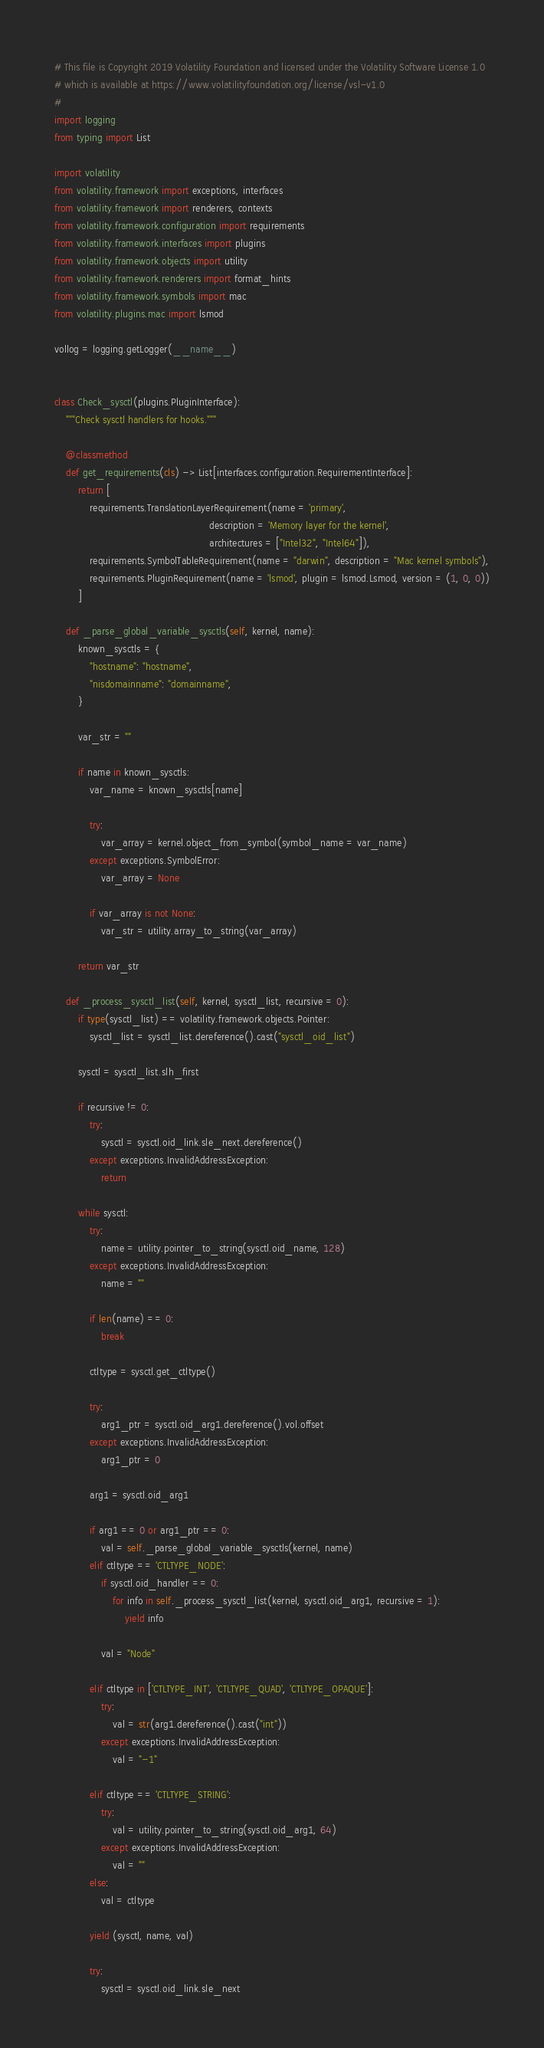Convert code to text. <code><loc_0><loc_0><loc_500><loc_500><_Python_># This file is Copyright 2019 Volatility Foundation and licensed under the Volatility Software License 1.0
# which is available at https://www.volatilityfoundation.org/license/vsl-v1.0
#
import logging
from typing import List

import volatility
from volatility.framework import exceptions, interfaces
from volatility.framework import renderers, contexts
from volatility.framework.configuration import requirements
from volatility.framework.interfaces import plugins
from volatility.framework.objects import utility
from volatility.framework.renderers import format_hints
from volatility.framework.symbols import mac
from volatility.plugins.mac import lsmod

vollog = logging.getLogger(__name__)


class Check_sysctl(plugins.PluginInterface):
    """Check sysctl handlers for hooks."""

    @classmethod
    def get_requirements(cls) -> List[interfaces.configuration.RequirementInterface]:
        return [
            requirements.TranslationLayerRequirement(name = 'primary',
                                                     description = 'Memory layer for the kernel',
                                                     architectures = ["Intel32", "Intel64"]),
            requirements.SymbolTableRequirement(name = "darwin", description = "Mac kernel symbols"),
            requirements.PluginRequirement(name = 'lsmod', plugin = lsmod.Lsmod, version = (1, 0, 0))
        ]

    def _parse_global_variable_sysctls(self, kernel, name):
        known_sysctls = {
            "hostname": "hostname",
            "nisdomainname": "domainname",
        }

        var_str = ""

        if name in known_sysctls:
            var_name = known_sysctls[name]

            try:
                var_array = kernel.object_from_symbol(symbol_name = var_name)
            except exceptions.SymbolError:
                var_array = None

            if var_array is not None:
                var_str = utility.array_to_string(var_array)

        return var_str

    def _process_sysctl_list(self, kernel, sysctl_list, recursive = 0):
        if type(sysctl_list) == volatility.framework.objects.Pointer:
            sysctl_list = sysctl_list.dereference().cast("sysctl_oid_list")

        sysctl = sysctl_list.slh_first

        if recursive != 0:
            try:
                sysctl = sysctl.oid_link.sle_next.dereference()
            except exceptions.InvalidAddressException:
                return

        while sysctl:
            try:
                name = utility.pointer_to_string(sysctl.oid_name, 128)
            except exceptions.InvalidAddressException:
                name = ""

            if len(name) == 0:
                break

            ctltype = sysctl.get_ctltype()

            try:
                arg1_ptr = sysctl.oid_arg1.dereference().vol.offset
            except exceptions.InvalidAddressException:
                arg1_ptr = 0

            arg1 = sysctl.oid_arg1

            if arg1 == 0 or arg1_ptr == 0:
                val = self._parse_global_variable_sysctls(kernel, name)
            elif ctltype == 'CTLTYPE_NODE':
                if sysctl.oid_handler == 0:
                    for info in self._process_sysctl_list(kernel, sysctl.oid_arg1, recursive = 1):
                        yield info

                val = "Node"

            elif ctltype in ['CTLTYPE_INT', 'CTLTYPE_QUAD', 'CTLTYPE_OPAQUE']:
                try:
                    val = str(arg1.dereference().cast("int"))
                except exceptions.InvalidAddressException:
                    val = "-1"

            elif ctltype == 'CTLTYPE_STRING':
                try:
                    val = utility.pointer_to_string(sysctl.oid_arg1, 64)
                except exceptions.InvalidAddressException:
                    val = ""
            else:
                val = ctltype

            yield (sysctl, name, val)

            try:
                sysctl = sysctl.oid_link.sle_next</code> 